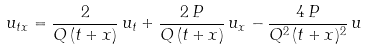Convert formula to latex. <formula><loc_0><loc_0><loc_500><loc_500>u _ { t x } = \frac { 2 } { Q \, ( t + x ) } \, u _ { t } + \frac { 2 \, P } { Q \, ( t + x ) } \, u _ { x } - \frac { 4 \, P } { Q ^ { 2 } \, ( t + x ) ^ { 2 } } \, u</formula> 